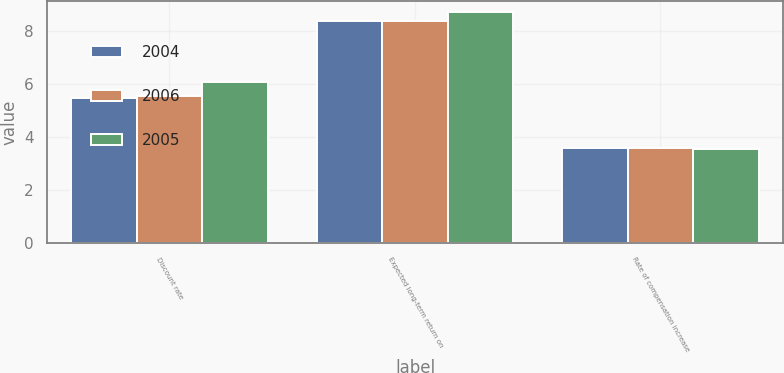Convert chart to OTSL. <chart><loc_0><loc_0><loc_500><loc_500><stacked_bar_chart><ecel><fcel>Discount rate<fcel>Expected long-term return on<fcel>Rate of compensation increase<nl><fcel>2004<fcel>5.49<fcel>8.39<fcel>3.6<nl><fcel>2006<fcel>5.57<fcel>8.41<fcel>3.59<nl><fcel>2005<fcel>6.08<fcel>8.73<fcel>3.57<nl></chart> 